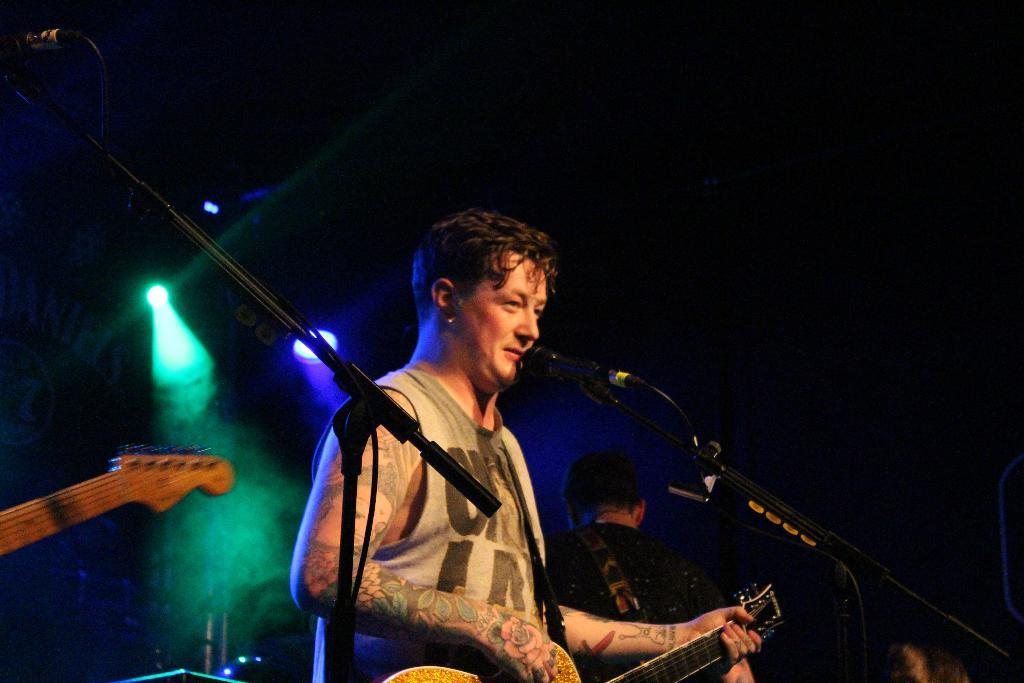What is the person in the image holding? The person is holding a guitar. What is in front of the person holding the guitar? There is a microphone and a microphone stand in front of the person. Can you describe the position of the second person in the image? The second person is standing behind the first person. What can be seen in the background of the image? There are lights in the background of the image. What type of disease is the person holding the guitar suffering from in the image? There is no indication of any disease in the image; the person is simply holding a guitar. Can you tell me how many pets are visible in the image? There are no pets present in the image. 